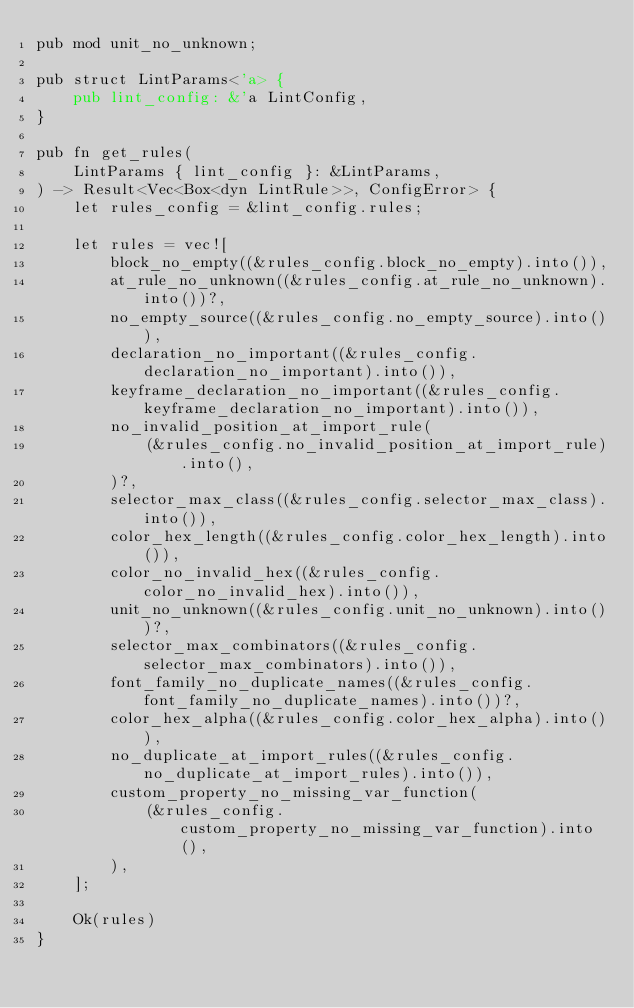<code> <loc_0><loc_0><loc_500><loc_500><_Rust_>pub mod unit_no_unknown;

pub struct LintParams<'a> {
    pub lint_config: &'a LintConfig,
}

pub fn get_rules(
    LintParams { lint_config }: &LintParams,
) -> Result<Vec<Box<dyn LintRule>>, ConfigError> {
    let rules_config = &lint_config.rules;

    let rules = vec![
        block_no_empty((&rules_config.block_no_empty).into()),
        at_rule_no_unknown((&rules_config.at_rule_no_unknown).into())?,
        no_empty_source((&rules_config.no_empty_source).into()),
        declaration_no_important((&rules_config.declaration_no_important).into()),
        keyframe_declaration_no_important((&rules_config.keyframe_declaration_no_important).into()),
        no_invalid_position_at_import_rule(
            (&rules_config.no_invalid_position_at_import_rule).into(),
        )?,
        selector_max_class((&rules_config.selector_max_class).into()),
        color_hex_length((&rules_config.color_hex_length).into()),
        color_no_invalid_hex((&rules_config.color_no_invalid_hex).into()),
        unit_no_unknown((&rules_config.unit_no_unknown).into())?,
        selector_max_combinators((&rules_config.selector_max_combinators).into()),
        font_family_no_duplicate_names((&rules_config.font_family_no_duplicate_names).into())?,
        color_hex_alpha((&rules_config.color_hex_alpha).into()),
        no_duplicate_at_import_rules((&rules_config.no_duplicate_at_import_rules).into()),
        custom_property_no_missing_var_function(
            (&rules_config.custom_property_no_missing_var_function).into(),
        ),
    ];

    Ok(rules)
}
</code> 